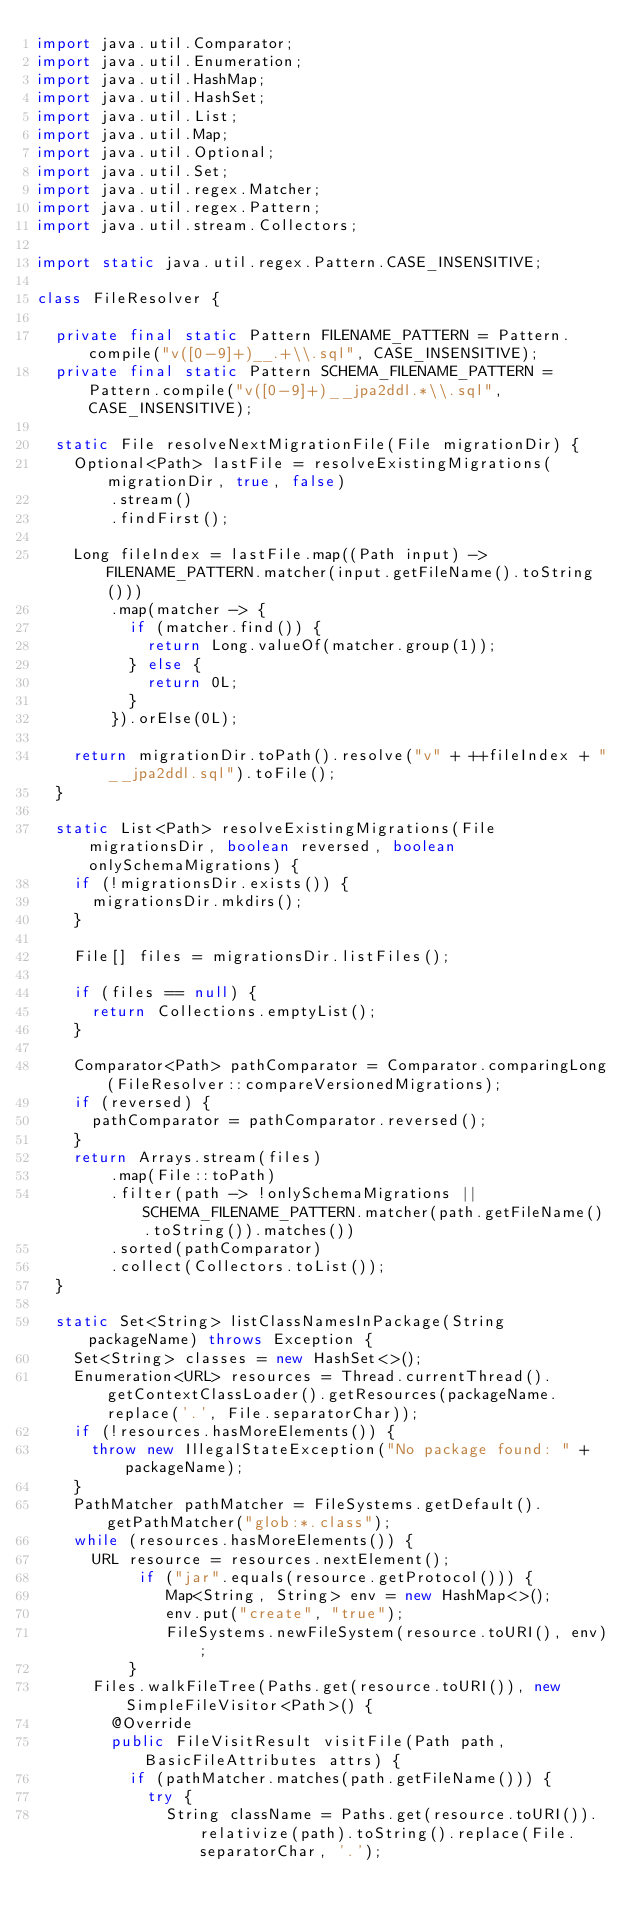<code> <loc_0><loc_0><loc_500><loc_500><_Java_>import java.util.Comparator;
import java.util.Enumeration;
import java.util.HashMap;
import java.util.HashSet;
import java.util.List;
import java.util.Map;
import java.util.Optional;
import java.util.Set;
import java.util.regex.Matcher;
import java.util.regex.Pattern;
import java.util.stream.Collectors;

import static java.util.regex.Pattern.CASE_INSENSITIVE;

class FileResolver {

	private final static Pattern FILENAME_PATTERN = Pattern.compile("v([0-9]+)__.+\\.sql", CASE_INSENSITIVE);
	private final static Pattern SCHEMA_FILENAME_PATTERN = Pattern.compile("v([0-9]+)__jpa2ddl.*\\.sql", CASE_INSENSITIVE);

	static File resolveNextMigrationFile(File migrationDir) {
		Optional<Path> lastFile = resolveExistingMigrations(migrationDir, true, false)
				.stream()
				.findFirst();
		
		Long fileIndex = lastFile.map((Path input) -> FILENAME_PATTERN.matcher(input.getFileName().toString()))
				.map(matcher -> {
					if (matcher.find()) {
						return Long.valueOf(matcher.group(1));
					} else {
						return 0L;
					}
				}).orElse(0L);

		return migrationDir.toPath().resolve("v" + ++fileIndex + "__jpa2ddl.sql").toFile();
	}

	static List<Path> resolveExistingMigrations(File migrationsDir, boolean reversed, boolean onlySchemaMigrations) {
		if (!migrationsDir.exists()) {
			migrationsDir.mkdirs();
		}

		File[] files = migrationsDir.listFiles();

		if (files == null) {
			return Collections.emptyList();
		}

		Comparator<Path> pathComparator = Comparator.comparingLong(FileResolver::compareVersionedMigrations);
		if (reversed) {
			pathComparator = pathComparator.reversed();
		}
		return Arrays.stream(files)
				.map(File::toPath)
				.filter(path -> !onlySchemaMigrations || SCHEMA_FILENAME_PATTERN.matcher(path.getFileName().toString()).matches())
				.sorted(pathComparator)
				.collect(Collectors.toList());
	}

	static Set<String> listClassNamesInPackage(String packageName) throws Exception {
		Set<String> classes = new HashSet<>();
		Enumeration<URL> resources = Thread.currentThread().getContextClassLoader().getResources(packageName.replace('.', File.separatorChar));
		if (!resources.hasMoreElements()) {
			throw new IllegalStateException("No package found: " + packageName);
		}
		PathMatcher pathMatcher = FileSystems.getDefault().getPathMatcher("glob:*.class");
		while (resources.hasMoreElements()) {
			URL resource = resources.nextElement();
	         if ("jar".equals(resource.getProtocol())) {
	            Map<String, String> env = new HashMap<>(); 
	            env.put("create", "true");
	            FileSystems.newFileSystem(resource.toURI(), env);
	        }
			Files.walkFileTree(Paths.get(resource.toURI()), new SimpleFileVisitor<Path>() {
				@Override
				public FileVisitResult visitFile(Path path, BasicFileAttributes attrs) {
					if (pathMatcher.matches(path.getFileName())) {
						try {
							String className = Paths.get(resource.toURI()).relativize(path).toString().replace(File.separatorChar, '.');</code> 